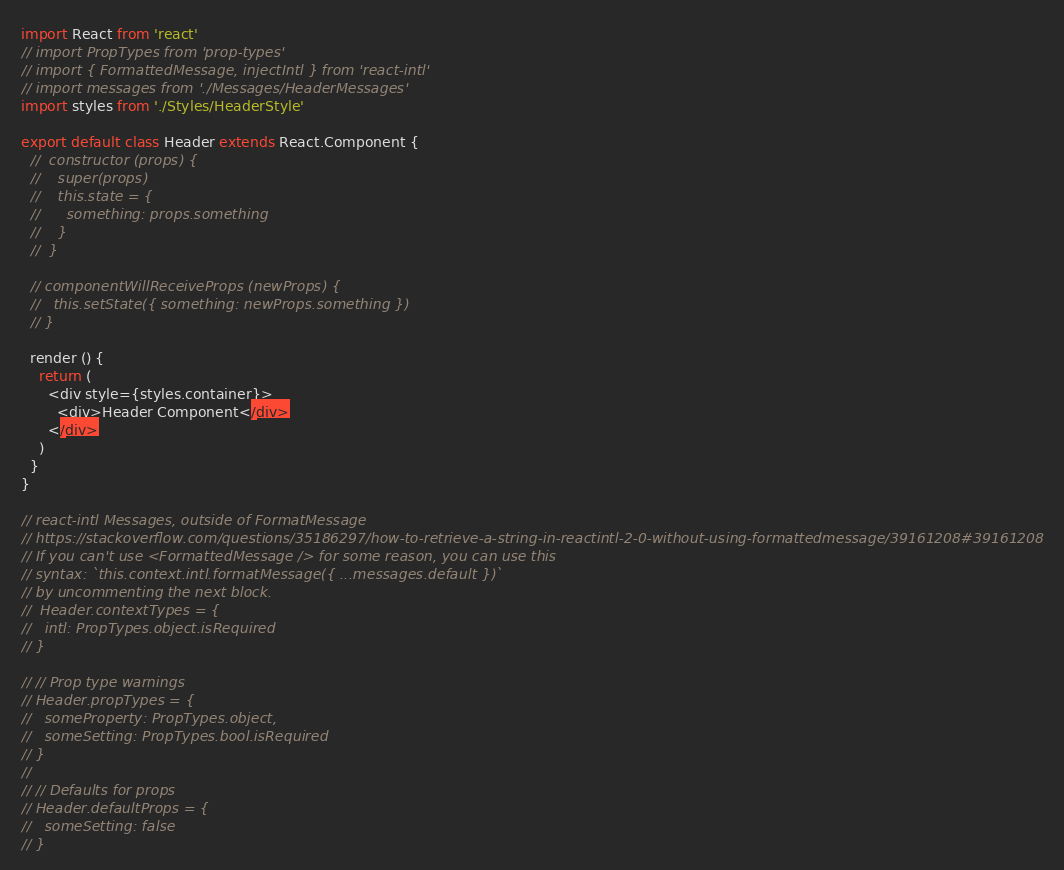<code> <loc_0><loc_0><loc_500><loc_500><_JavaScript_>import React from 'react'
// import PropTypes from 'prop-types'
// import { FormattedMessage, injectIntl } from 'react-intl'
// import messages from './Messages/HeaderMessages'
import styles from './Styles/HeaderStyle'

export default class Header extends React.Component {
  //  constructor (props) {
  //    super(props)
  //    this.state = {
  //      something: props.something
  //    }
  //  }

  // componentWillReceiveProps (newProps) {
  //   this.setState({ something: newProps.something })
  // }

  render () {
    return (
      <div style={styles.container}>
        <div>Header Component</div>
      </div>
    )
  }
}

// react-intl Messages, outside of FormatMessage
// https://stackoverflow.com/questions/35186297/how-to-retrieve-a-string-in-reactintl-2-0-without-using-formattedmessage/39161208#39161208
// If you can't use <FormattedMessage /> for some reason, you can use this
// syntax: `this.context.intl.formatMessage({ ...messages.default })`
// by uncommenting the next block.
//  Header.contextTypes = {
//   intl: PropTypes.object.isRequired
// }

// // Prop type warnings
// Header.propTypes = {
//   someProperty: PropTypes.object,
//   someSetting: PropTypes.bool.isRequired
// }
//
// // Defaults for props
// Header.defaultProps = {
//   someSetting: false
// }
</code> 